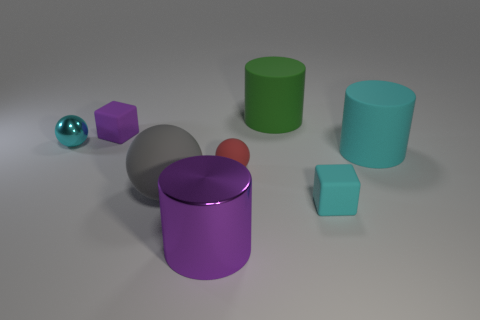What is the material of the small block that is the same color as the big metal object?
Make the answer very short. Rubber. Are there fewer red objects that are in front of the red matte sphere than cyan matte cylinders on the left side of the gray rubber sphere?
Provide a short and direct response. No. What number of things are either small objects that are on the right side of the purple cube or large spheres?
Your answer should be compact. 3. What shape is the metallic thing that is on the left side of the purple thing behind the cyan rubber block?
Ensure brevity in your answer.  Sphere. Are there any green cubes that have the same size as the cyan ball?
Provide a short and direct response. No. Are there more small purple rubber spheres than red matte balls?
Provide a succinct answer. No. There is a cyan object that is on the left side of the green thing; is it the same size as the cube that is on the right side of the purple metallic object?
Give a very brief answer. Yes. How many big objects are in front of the cyan metallic object and on the right side of the red sphere?
Your response must be concise. 1. There is another big rubber thing that is the same shape as the big green rubber object; what is its color?
Your response must be concise. Cyan. Are there fewer big rubber things than big gray shiny things?
Your answer should be very brief. No. 